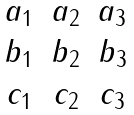<formula> <loc_0><loc_0><loc_500><loc_500>\begin{matrix} a _ { 1 } & a _ { 2 } & a _ { 3 } \\ b _ { 1 } & b _ { 2 } & b _ { 3 } \\ c _ { 1 } & c _ { 2 } & c _ { 3 } \\ \end{matrix}</formula> 